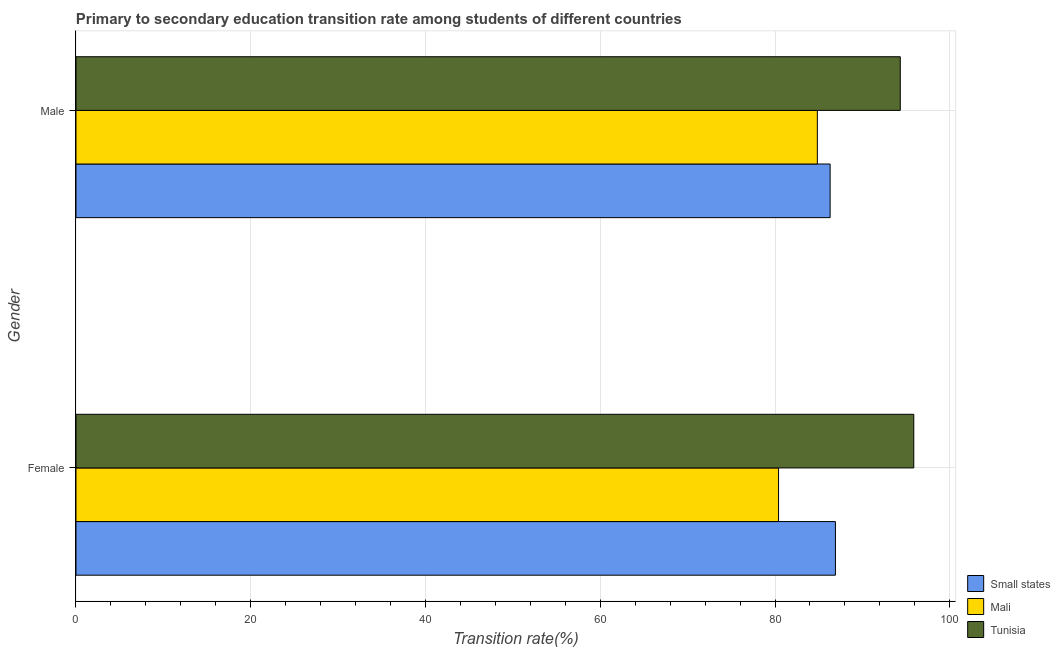How many different coloured bars are there?
Your answer should be compact. 3. Are the number of bars on each tick of the Y-axis equal?
Offer a very short reply. Yes. How many bars are there on the 2nd tick from the top?
Ensure brevity in your answer.  3. What is the label of the 2nd group of bars from the top?
Ensure brevity in your answer.  Female. What is the transition rate among female students in Small states?
Make the answer very short. 86.92. Across all countries, what is the maximum transition rate among female students?
Keep it short and to the point. 95.88. Across all countries, what is the minimum transition rate among female students?
Your response must be concise. 80.41. In which country was the transition rate among male students maximum?
Give a very brief answer. Tunisia. In which country was the transition rate among female students minimum?
Ensure brevity in your answer.  Mali. What is the total transition rate among male students in the graph?
Keep it short and to the point. 265.5. What is the difference between the transition rate among female students in Tunisia and that in Mali?
Provide a short and direct response. 15.48. What is the difference between the transition rate among male students in Small states and the transition rate among female students in Mali?
Your answer should be very brief. 5.9. What is the average transition rate among male students per country?
Your answer should be very brief. 88.5. What is the difference between the transition rate among male students and transition rate among female students in Small states?
Offer a very short reply. -0.61. In how many countries, is the transition rate among female students greater than 88 %?
Provide a short and direct response. 1. What is the ratio of the transition rate among male students in Small states to that in Tunisia?
Ensure brevity in your answer.  0.91. Is the transition rate among male students in Small states less than that in Tunisia?
Provide a short and direct response. Yes. In how many countries, is the transition rate among female students greater than the average transition rate among female students taken over all countries?
Provide a succinct answer. 1. What does the 1st bar from the top in Male represents?
Give a very brief answer. Tunisia. What does the 1st bar from the bottom in Female represents?
Keep it short and to the point. Small states. Does the graph contain any zero values?
Provide a succinct answer. No. Does the graph contain grids?
Offer a very short reply. Yes. Where does the legend appear in the graph?
Offer a very short reply. Bottom right. What is the title of the graph?
Keep it short and to the point. Primary to secondary education transition rate among students of different countries. What is the label or title of the X-axis?
Provide a short and direct response. Transition rate(%). What is the label or title of the Y-axis?
Keep it short and to the point. Gender. What is the Transition rate(%) of Small states in Female?
Your answer should be very brief. 86.92. What is the Transition rate(%) in Mali in Female?
Your answer should be compact. 80.41. What is the Transition rate(%) in Tunisia in Female?
Ensure brevity in your answer.  95.88. What is the Transition rate(%) of Small states in Male?
Your answer should be very brief. 86.31. What is the Transition rate(%) of Mali in Male?
Your answer should be compact. 84.85. What is the Transition rate(%) of Tunisia in Male?
Ensure brevity in your answer.  94.34. Across all Gender, what is the maximum Transition rate(%) in Small states?
Keep it short and to the point. 86.92. Across all Gender, what is the maximum Transition rate(%) in Mali?
Offer a terse response. 84.85. Across all Gender, what is the maximum Transition rate(%) in Tunisia?
Your response must be concise. 95.88. Across all Gender, what is the minimum Transition rate(%) in Small states?
Ensure brevity in your answer.  86.31. Across all Gender, what is the minimum Transition rate(%) of Mali?
Keep it short and to the point. 80.41. Across all Gender, what is the minimum Transition rate(%) in Tunisia?
Your answer should be compact. 94.34. What is the total Transition rate(%) in Small states in the graph?
Your response must be concise. 173.22. What is the total Transition rate(%) in Mali in the graph?
Provide a short and direct response. 165.25. What is the total Transition rate(%) of Tunisia in the graph?
Ensure brevity in your answer.  190.22. What is the difference between the Transition rate(%) of Small states in Female and that in Male?
Ensure brevity in your answer.  0.61. What is the difference between the Transition rate(%) in Mali in Female and that in Male?
Keep it short and to the point. -4.44. What is the difference between the Transition rate(%) of Tunisia in Female and that in Male?
Make the answer very short. 1.54. What is the difference between the Transition rate(%) of Small states in Female and the Transition rate(%) of Mali in Male?
Offer a terse response. 2.07. What is the difference between the Transition rate(%) of Small states in Female and the Transition rate(%) of Tunisia in Male?
Offer a terse response. -7.42. What is the difference between the Transition rate(%) in Mali in Female and the Transition rate(%) in Tunisia in Male?
Your response must be concise. -13.93. What is the average Transition rate(%) in Small states per Gender?
Your answer should be very brief. 86.61. What is the average Transition rate(%) of Mali per Gender?
Provide a short and direct response. 82.63. What is the average Transition rate(%) in Tunisia per Gender?
Offer a terse response. 95.11. What is the difference between the Transition rate(%) of Small states and Transition rate(%) of Mali in Female?
Your response must be concise. 6.51. What is the difference between the Transition rate(%) of Small states and Transition rate(%) of Tunisia in Female?
Make the answer very short. -8.97. What is the difference between the Transition rate(%) in Mali and Transition rate(%) in Tunisia in Female?
Offer a very short reply. -15.48. What is the difference between the Transition rate(%) in Small states and Transition rate(%) in Mali in Male?
Give a very brief answer. 1.46. What is the difference between the Transition rate(%) of Small states and Transition rate(%) of Tunisia in Male?
Give a very brief answer. -8.03. What is the difference between the Transition rate(%) of Mali and Transition rate(%) of Tunisia in Male?
Keep it short and to the point. -9.49. What is the ratio of the Transition rate(%) in Small states in Female to that in Male?
Give a very brief answer. 1.01. What is the ratio of the Transition rate(%) in Mali in Female to that in Male?
Make the answer very short. 0.95. What is the ratio of the Transition rate(%) in Tunisia in Female to that in Male?
Give a very brief answer. 1.02. What is the difference between the highest and the second highest Transition rate(%) of Small states?
Your answer should be very brief. 0.61. What is the difference between the highest and the second highest Transition rate(%) in Mali?
Your response must be concise. 4.44. What is the difference between the highest and the second highest Transition rate(%) in Tunisia?
Offer a very short reply. 1.54. What is the difference between the highest and the lowest Transition rate(%) in Small states?
Make the answer very short. 0.61. What is the difference between the highest and the lowest Transition rate(%) in Mali?
Make the answer very short. 4.44. What is the difference between the highest and the lowest Transition rate(%) of Tunisia?
Your answer should be compact. 1.54. 